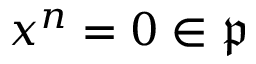<formula> <loc_0><loc_0><loc_500><loc_500>x ^ { n } = 0 \in { \mathfrak { p } }</formula> 